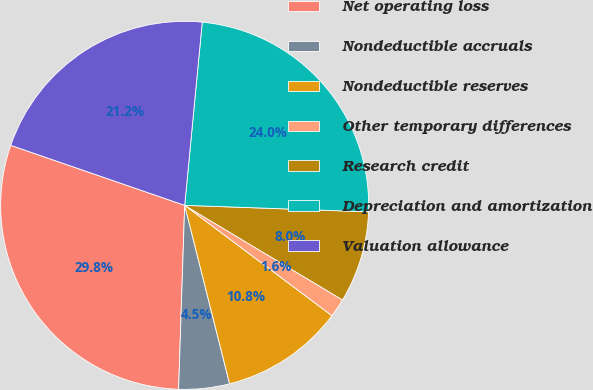Convert chart to OTSL. <chart><loc_0><loc_0><loc_500><loc_500><pie_chart><fcel>Net operating loss<fcel>Nondeductible accruals<fcel>Nondeductible reserves<fcel>Other temporary differences<fcel>Research credit<fcel>Depreciation and amortization<fcel>Valuation allowance<nl><fcel>29.76%<fcel>4.45%<fcel>10.84%<fcel>1.64%<fcel>8.03%<fcel>24.04%<fcel>21.23%<nl></chart> 